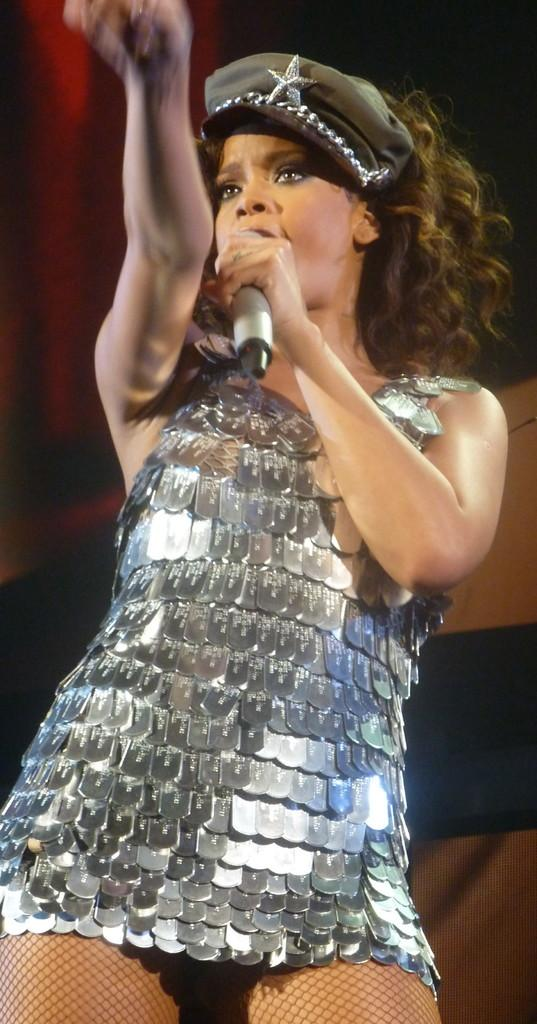What is the main subject of the image? There is a person in the image. What is the person holding in the image? The person is holding a microphone. What can be seen in the background of the image? There is a curtain in the background of the image. Can you see any turkeys or lettuce in the image? No, there are no turkeys or lettuce present in the image. 